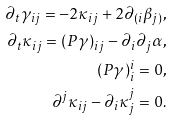<formula> <loc_0><loc_0><loc_500><loc_500>\partial _ { t } \gamma _ { i j } = - 2 \kappa _ { i j } + 2 \partial _ { ( i } \beta _ { j ) } , \\ \partial _ { t } \kappa _ { i j } = ( P \gamma ) _ { i j } - \partial _ { i } \partial _ { j } \alpha , \\ ( P \gamma ) ^ { i } _ { i } = 0 , \\ \partial ^ { j } \kappa _ { i j } - \partial _ { i } \kappa ^ { j } _ { j } = 0 .</formula> 